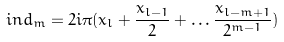Convert formula to latex. <formula><loc_0><loc_0><loc_500><loc_500>i n d _ { m } = 2 i \pi ( x _ { l } + \frac { x _ { l - 1 } } { 2 } + \dots \frac { x _ { l - m + 1 } } { 2 ^ { m - 1 } } )</formula> 